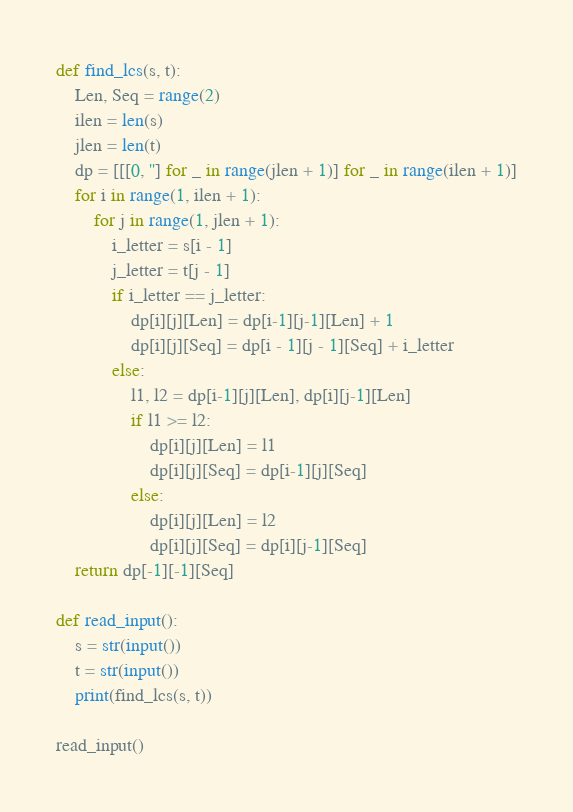<code> <loc_0><loc_0><loc_500><loc_500><_Python_>def find_lcs(s, t):
    Len, Seq = range(2)
    ilen = len(s)
    jlen = len(t)
    dp = [[[0, ''] for _ in range(jlen + 1)] for _ in range(ilen + 1)]
    for i in range(1, ilen + 1):
        for j in range(1, jlen + 1):
            i_letter = s[i - 1]
            j_letter = t[j - 1]
            if i_letter == j_letter:
                dp[i][j][Len] = dp[i-1][j-1][Len] + 1
                dp[i][j][Seq] = dp[i - 1][j - 1][Seq] + i_letter
            else:
                l1, l2 = dp[i-1][j][Len], dp[i][j-1][Len]
                if l1 >= l2:
                    dp[i][j][Len] = l1
                    dp[i][j][Seq] = dp[i-1][j][Seq]
                else:
                    dp[i][j][Len] = l2
                    dp[i][j][Seq] = dp[i][j-1][Seq]
    return dp[-1][-1][Seq]
 
def read_input():
    s = str(input())
    t = str(input())
    print(find_lcs(s, t))
    
read_input()</code> 